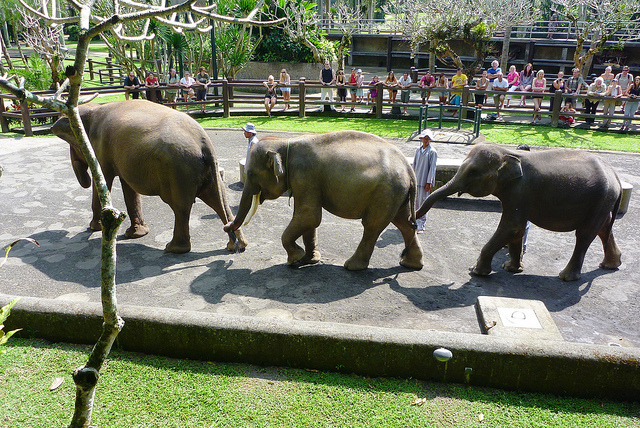<image>Which animal has the longest horns? It is unknown which animal has the longest horns. It seems to be ambiguous. Which animal has the longest horns? I don't know which animal has the longest horns. It is not mentioned in the given answers. 